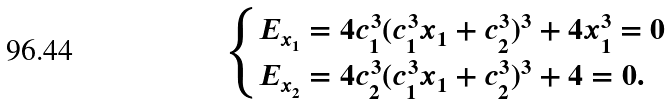Convert formula to latex. <formula><loc_0><loc_0><loc_500><loc_500>\begin{cases} E _ { x _ { 1 } } = 4 c _ { 1 } ^ { 3 } ( c _ { 1 } ^ { 3 } x _ { 1 } + c _ { 2 } ^ { 3 } ) ^ { 3 } + 4 x _ { 1 } ^ { 3 } = 0 \\ E _ { x _ { 2 } } = 4 c _ { 2 } ^ { 3 } ( c _ { 1 } ^ { 3 } x _ { 1 } + c _ { 2 } ^ { 3 } ) ^ { 3 } + 4 = 0 . \end{cases}</formula> 